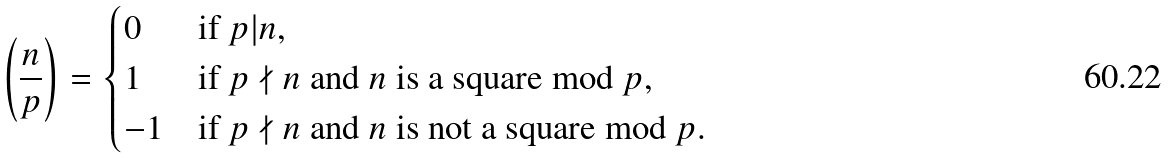<formula> <loc_0><loc_0><loc_500><loc_500>\left ( \frac { n } { p } \right ) = \begin{cases} 0 & \text {if $p | n$} , \\ 1 & \text {if $p \nmid n$ and $n$ is a square mod $p$} , \\ - 1 & \text {if $p \nmid n$ and $n$ is not a square mod $p$} . \end{cases}</formula> 